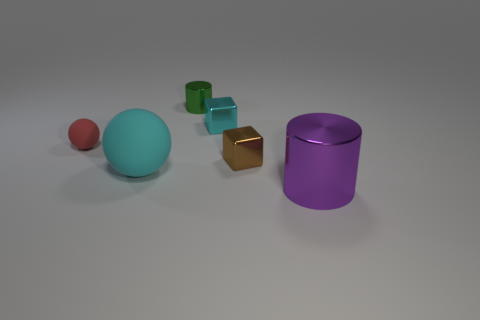What is the size of the purple cylinder that is the same material as the tiny brown cube?
Make the answer very short. Large. How many other tiny green objects are the same shape as the green shiny thing?
Give a very brief answer. 0. There is a block that is the same size as the brown thing; what material is it?
Offer a very short reply. Metal. Are there any cyan spheres made of the same material as the red thing?
Keep it short and to the point. Yes. There is a thing that is both in front of the brown object and to the left of the brown block; what color is it?
Offer a terse response. Cyan. How many other things are there of the same color as the small ball?
Your response must be concise. 0. The cylinder in front of the matte sphere behind the large thing that is left of the green thing is made of what material?
Offer a very short reply. Metal. What number of cylinders are brown shiny things or big gray rubber objects?
Make the answer very short. 0. There is a small metallic cube in front of the sphere that is behind the small brown metallic thing; what number of tiny spheres are right of it?
Your answer should be very brief. 0. Does the cyan rubber object have the same shape as the red object?
Keep it short and to the point. Yes. 